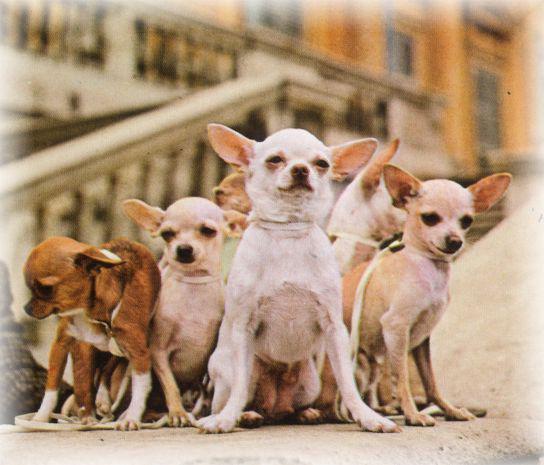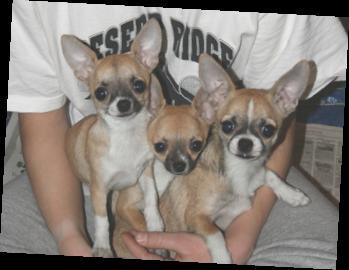The first image is the image on the left, the second image is the image on the right. For the images shown, is this caption "There are more than 10 dogs in the image on the left." true? Answer yes or no. No. 